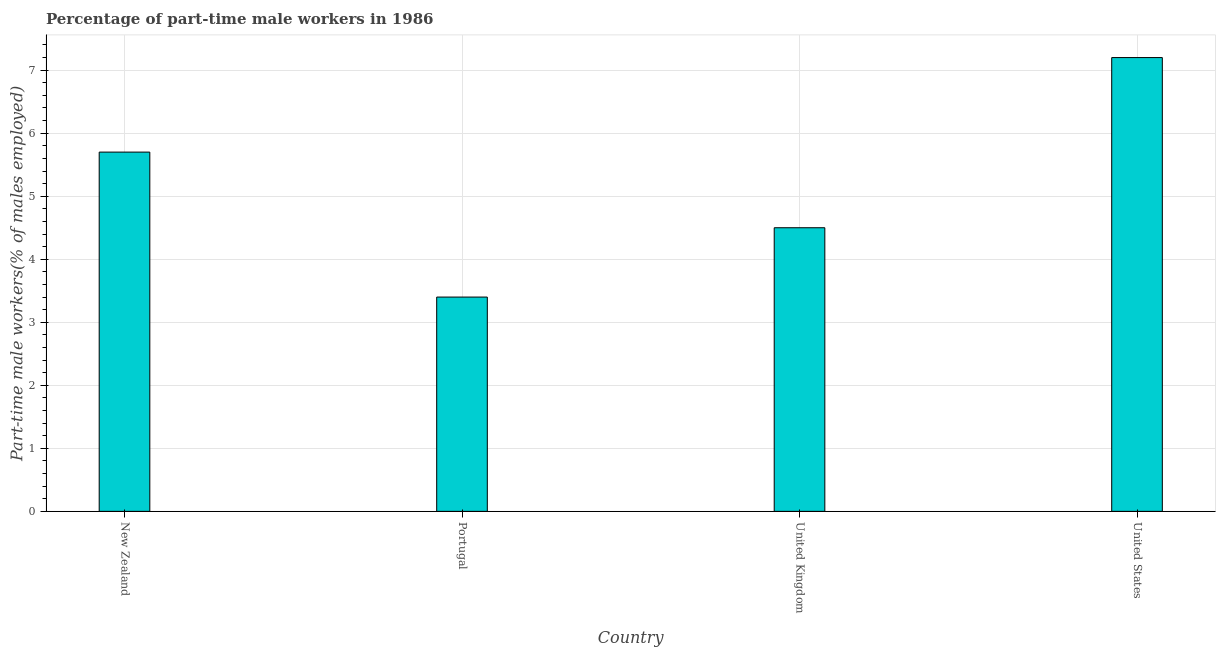Does the graph contain grids?
Give a very brief answer. Yes. What is the title of the graph?
Your answer should be compact. Percentage of part-time male workers in 1986. What is the label or title of the X-axis?
Ensure brevity in your answer.  Country. What is the label or title of the Y-axis?
Provide a succinct answer. Part-time male workers(% of males employed). What is the percentage of part-time male workers in Portugal?
Make the answer very short. 3.4. Across all countries, what is the maximum percentage of part-time male workers?
Make the answer very short. 7.2. Across all countries, what is the minimum percentage of part-time male workers?
Your answer should be compact. 3.4. In which country was the percentage of part-time male workers maximum?
Provide a short and direct response. United States. In which country was the percentage of part-time male workers minimum?
Provide a short and direct response. Portugal. What is the sum of the percentage of part-time male workers?
Provide a succinct answer. 20.8. What is the difference between the percentage of part-time male workers in New Zealand and United States?
Give a very brief answer. -1.5. What is the average percentage of part-time male workers per country?
Make the answer very short. 5.2. What is the median percentage of part-time male workers?
Make the answer very short. 5.1. What is the ratio of the percentage of part-time male workers in Portugal to that in United States?
Ensure brevity in your answer.  0.47. In how many countries, is the percentage of part-time male workers greater than the average percentage of part-time male workers taken over all countries?
Ensure brevity in your answer.  2. How many bars are there?
Offer a very short reply. 4. Are all the bars in the graph horizontal?
Your response must be concise. No. How many countries are there in the graph?
Provide a short and direct response. 4. Are the values on the major ticks of Y-axis written in scientific E-notation?
Ensure brevity in your answer.  No. What is the Part-time male workers(% of males employed) in New Zealand?
Your response must be concise. 5.7. What is the Part-time male workers(% of males employed) in Portugal?
Offer a very short reply. 3.4. What is the Part-time male workers(% of males employed) in United States?
Give a very brief answer. 7.2. What is the difference between the Part-time male workers(% of males employed) in New Zealand and Portugal?
Give a very brief answer. 2.3. What is the difference between the Part-time male workers(% of males employed) in Portugal and United Kingdom?
Offer a terse response. -1.1. What is the difference between the Part-time male workers(% of males employed) in United Kingdom and United States?
Your answer should be compact. -2.7. What is the ratio of the Part-time male workers(% of males employed) in New Zealand to that in Portugal?
Ensure brevity in your answer.  1.68. What is the ratio of the Part-time male workers(% of males employed) in New Zealand to that in United Kingdom?
Ensure brevity in your answer.  1.27. What is the ratio of the Part-time male workers(% of males employed) in New Zealand to that in United States?
Provide a succinct answer. 0.79. What is the ratio of the Part-time male workers(% of males employed) in Portugal to that in United Kingdom?
Keep it short and to the point. 0.76. What is the ratio of the Part-time male workers(% of males employed) in Portugal to that in United States?
Keep it short and to the point. 0.47. What is the ratio of the Part-time male workers(% of males employed) in United Kingdom to that in United States?
Offer a very short reply. 0.62. 